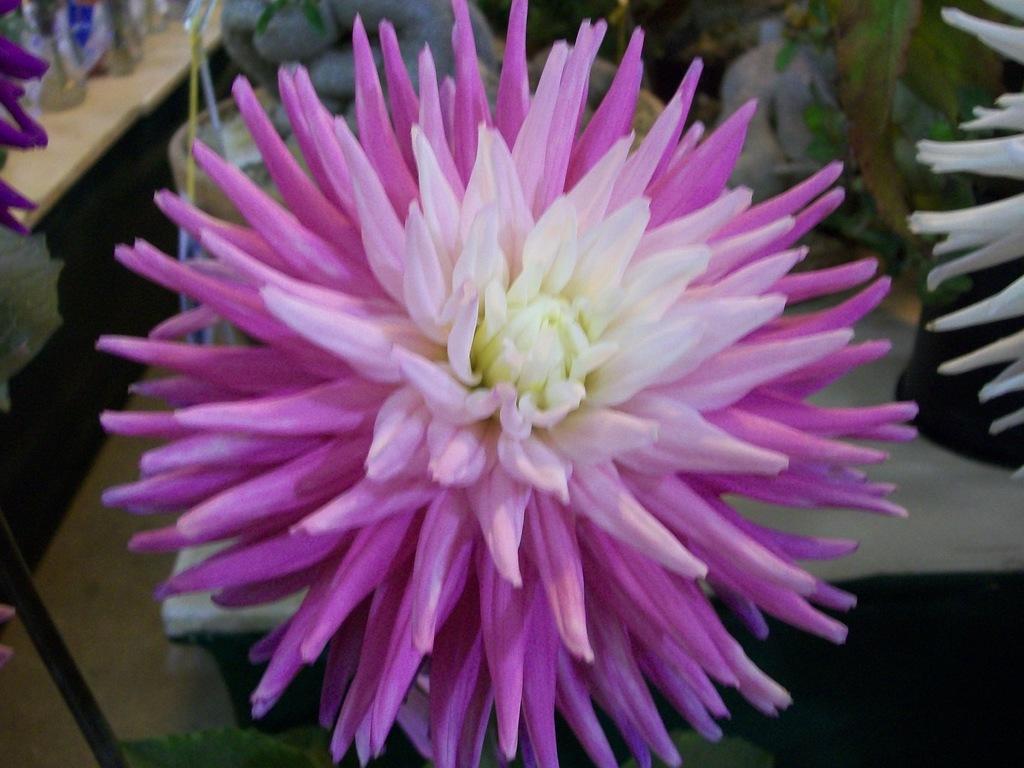How would you summarize this image in a sentence or two? In this image I can see flowering plants and pots on the table. This image is taken may be in a hall. 